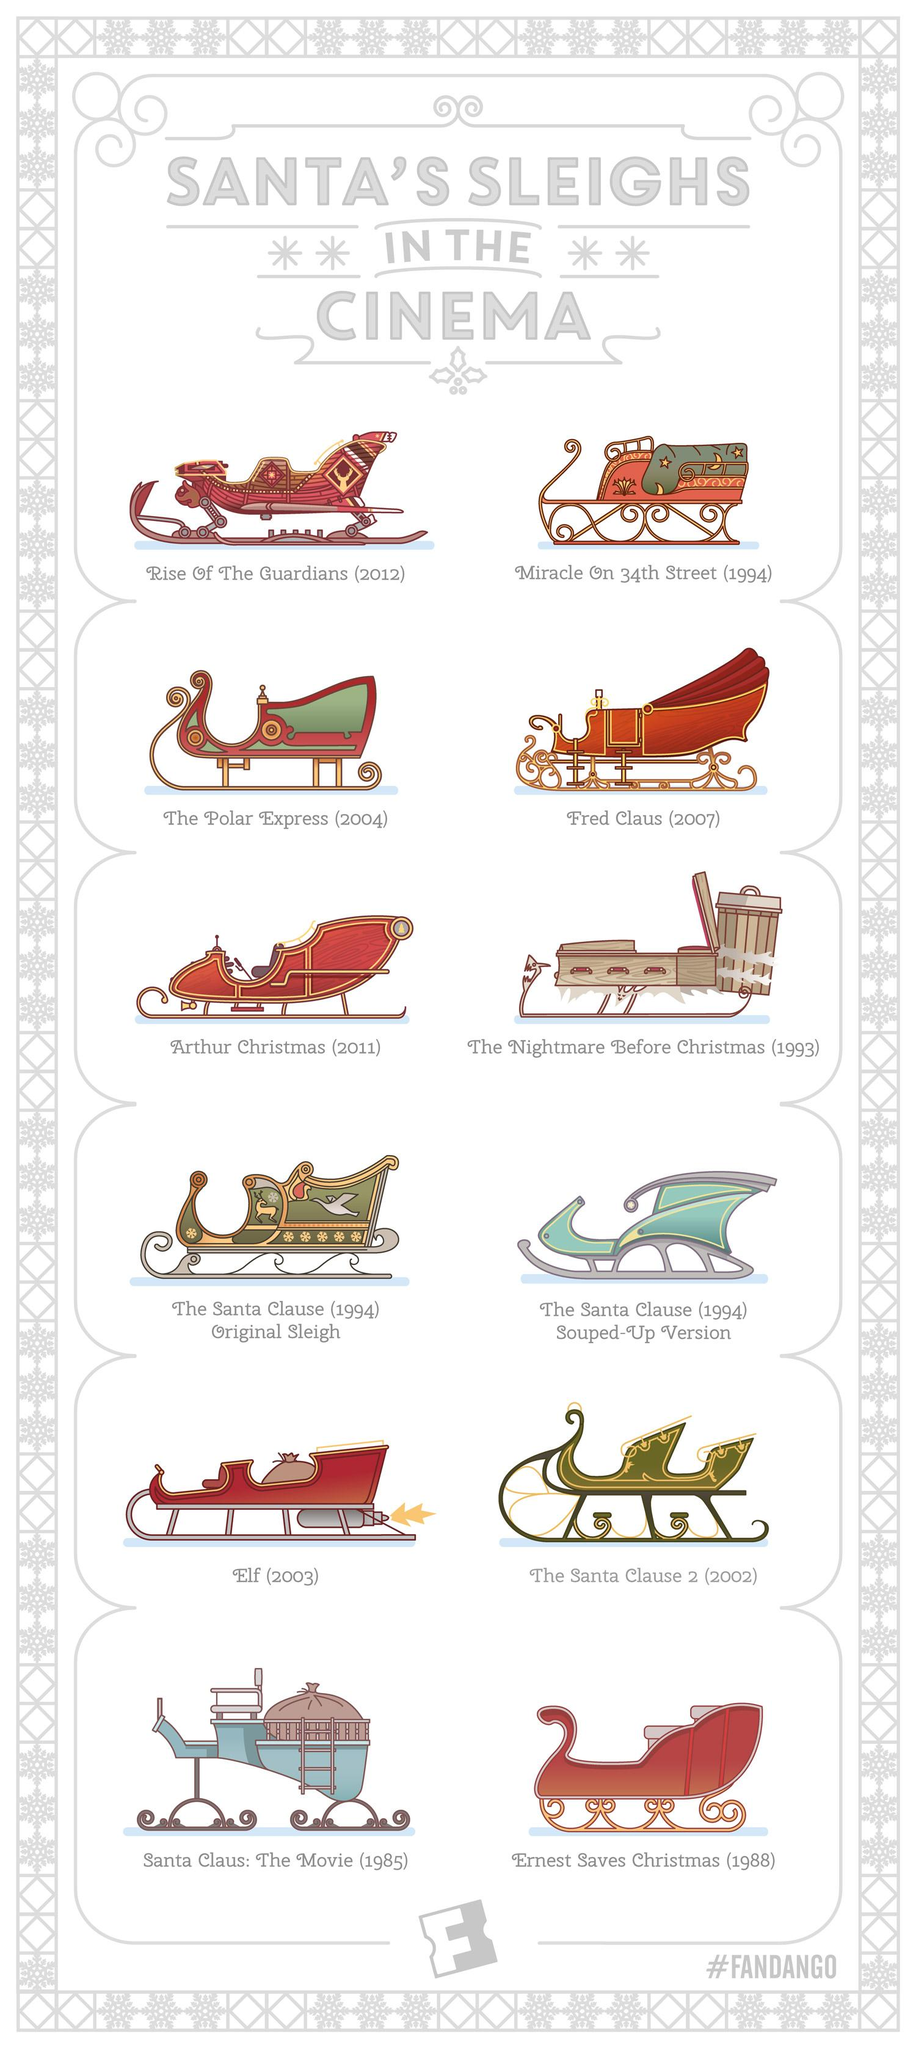List a handful of essential elements in this visual. The movies in question were shown in the cinema. The movies that were released in 1994 are "Miracle on 34th Street," "The Santa Clause (1994) Original Sleigh," and "The Santa Clause (1994) Souped-up Version. In the movies "Santa Claus: The Movie" and "Elf," Santa Claus is depicted as riding sleighs that contain bags. In the movie "The Nightmare Before Christmas," the body of the sleigh has three handles. In the film 'The Santa Clause 2', the color of Santa's sleigh is depicted as being green. 